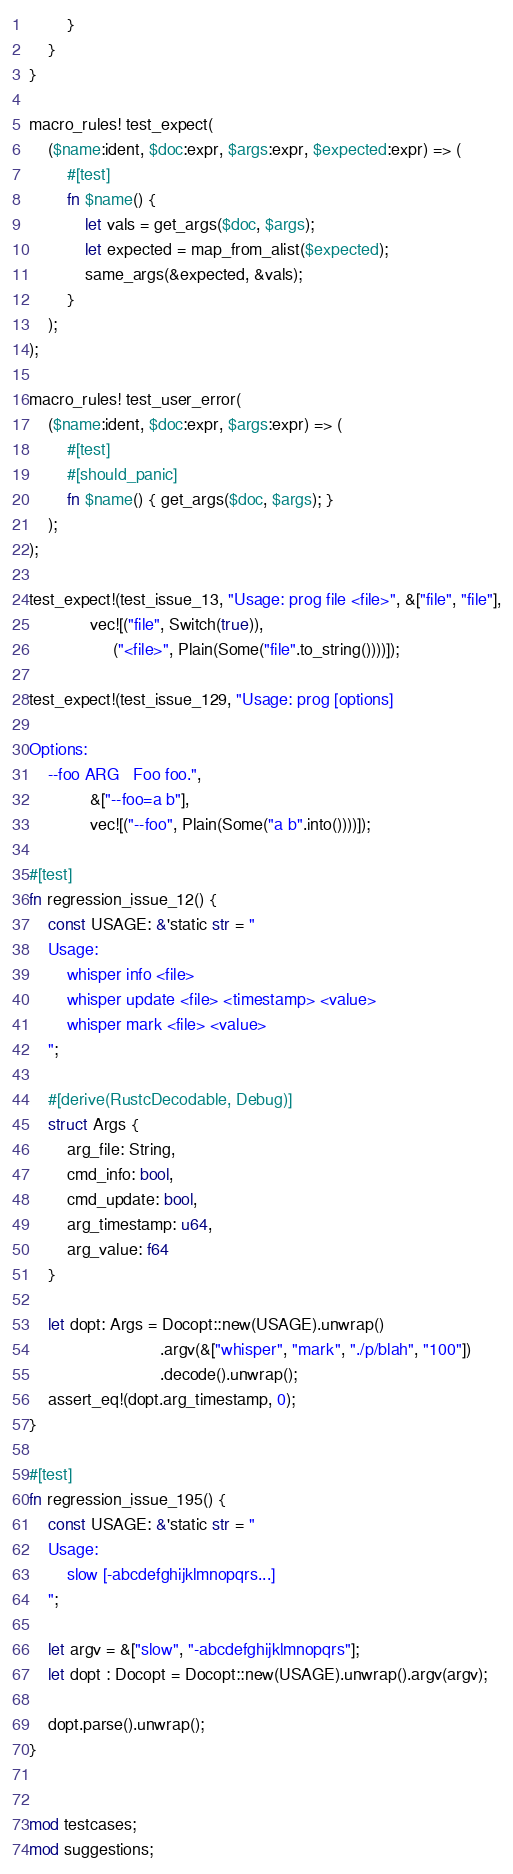<code> <loc_0><loc_0><loc_500><loc_500><_Rust_>        }
    }
}

macro_rules! test_expect(
    ($name:ident, $doc:expr, $args:expr, $expected:expr) => (
        #[test]
        fn $name() {
            let vals = get_args($doc, $args);
            let expected = map_from_alist($expected);
            same_args(&expected, &vals);
        }
    );
);

macro_rules! test_user_error(
    ($name:ident, $doc:expr, $args:expr) => (
        #[test]
        #[should_panic]
        fn $name() { get_args($doc, $args); }
    );
);

test_expect!(test_issue_13, "Usage: prog file <file>", &["file", "file"],
             vec![("file", Switch(true)),
                  ("<file>", Plain(Some("file".to_string())))]);

test_expect!(test_issue_129, "Usage: prog [options]

Options:
    --foo ARG   Foo foo.",
             &["--foo=a b"],
             vec![("--foo", Plain(Some("a b".into())))]);

#[test]
fn regression_issue_12() {
    const USAGE: &'static str = "
    Usage:
        whisper info <file>
        whisper update <file> <timestamp> <value>
        whisper mark <file> <value>
    ";

    #[derive(RustcDecodable, Debug)]
    struct Args {
        arg_file: String,
        cmd_info: bool,
        cmd_update: bool,
        arg_timestamp: u64,
        arg_value: f64
    }

    let dopt: Args = Docopt::new(USAGE).unwrap()
                            .argv(&["whisper", "mark", "./p/blah", "100"])
                            .decode().unwrap();
    assert_eq!(dopt.arg_timestamp, 0);
}

#[test]
fn regression_issue_195() {
    const USAGE: &'static str = "
    Usage:
        slow [-abcdefghijklmnopqrs...]
    ";

    let argv = &["slow", "-abcdefghijklmnopqrs"];
    let dopt : Docopt = Docopt::new(USAGE).unwrap().argv(argv);

    dopt.parse().unwrap();
}


mod testcases;
mod suggestions;
</code> 